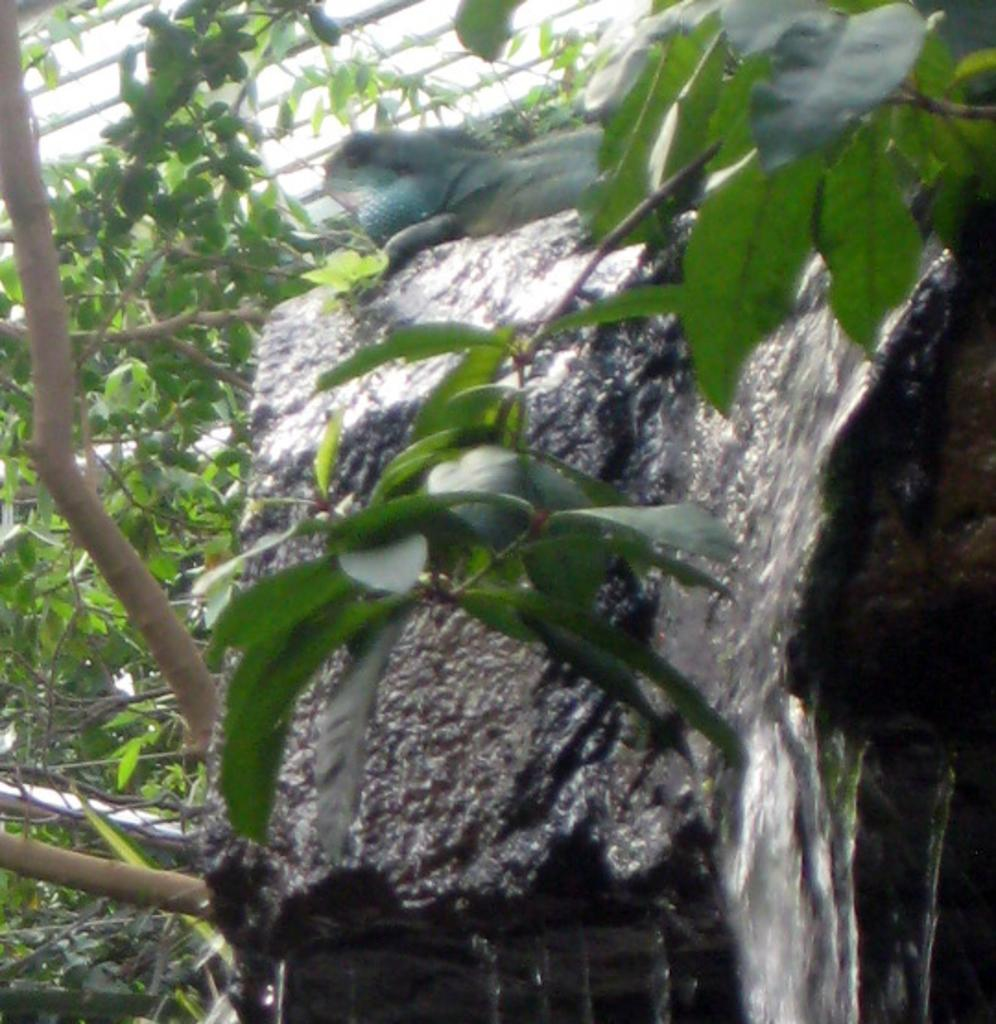What type of animal is on the stone in the image? There is a reptile on a stone in the image. What is happening to the stone in the image? Water is passing through the stone in the image. What can be seen on the left side of the image? There are trees on the left side of the image. What is present on the top of the image? There are rods on the top of the image. What type of plants can be seen growing on the reptile in the image? There are no plants growing on the reptile in the image. Is there a fire visible in the image? There is no fire visible in the image. Can you see a rabbit in the image? There is no rabbit present in the image. 